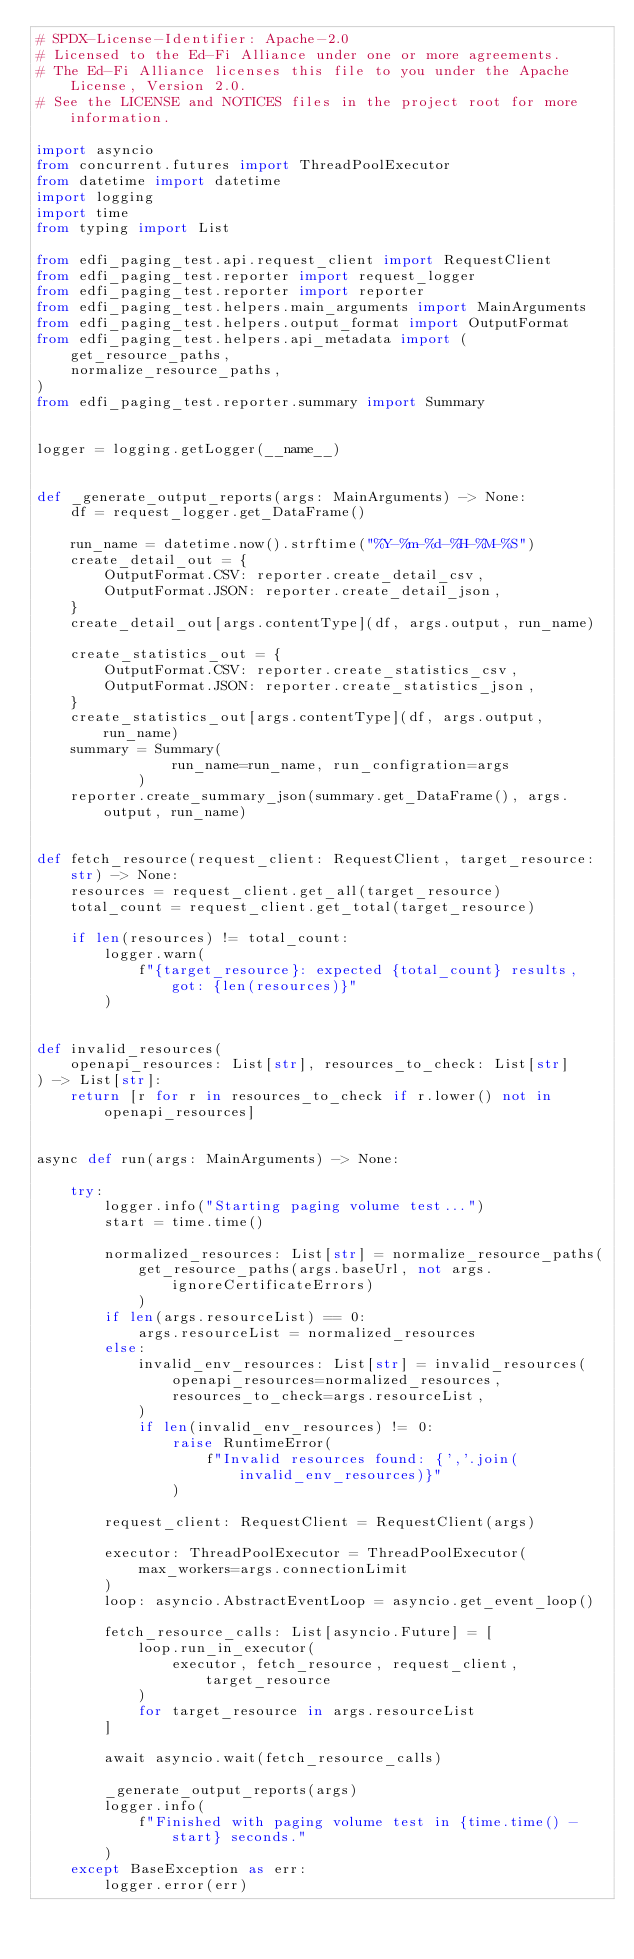<code> <loc_0><loc_0><loc_500><loc_500><_Python_># SPDX-License-Identifier: Apache-2.0
# Licensed to the Ed-Fi Alliance under one or more agreements.
# The Ed-Fi Alliance licenses this file to you under the Apache License, Version 2.0.
# See the LICENSE and NOTICES files in the project root for more information.

import asyncio
from concurrent.futures import ThreadPoolExecutor
from datetime import datetime
import logging
import time
from typing import List

from edfi_paging_test.api.request_client import RequestClient
from edfi_paging_test.reporter import request_logger
from edfi_paging_test.reporter import reporter
from edfi_paging_test.helpers.main_arguments import MainArguments
from edfi_paging_test.helpers.output_format import OutputFormat
from edfi_paging_test.helpers.api_metadata import (
    get_resource_paths,
    normalize_resource_paths,
)
from edfi_paging_test.reporter.summary import Summary


logger = logging.getLogger(__name__)


def _generate_output_reports(args: MainArguments) -> None:
    df = request_logger.get_DataFrame()

    run_name = datetime.now().strftime("%Y-%m-%d-%H-%M-%S")
    create_detail_out = {
        OutputFormat.CSV: reporter.create_detail_csv,
        OutputFormat.JSON: reporter.create_detail_json,
    }
    create_detail_out[args.contentType](df, args.output, run_name)

    create_statistics_out = {
        OutputFormat.CSV: reporter.create_statistics_csv,
        OutputFormat.JSON: reporter.create_statistics_json,
    }
    create_statistics_out[args.contentType](df, args.output, run_name)
    summary = Summary(
                run_name=run_name, run_configration=args
            )
    reporter.create_summary_json(summary.get_DataFrame(), args.output, run_name)


def fetch_resource(request_client: RequestClient, target_resource: str) -> None:
    resources = request_client.get_all(target_resource)
    total_count = request_client.get_total(target_resource)

    if len(resources) != total_count:
        logger.warn(
            f"{target_resource}: expected {total_count} results, got: {len(resources)}"
        )


def invalid_resources(
    openapi_resources: List[str], resources_to_check: List[str]
) -> List[str]:
    return [r for r in resources_to_check if r.lower() not in openapi_resources]


async def run(args: MainArguments) -> None:

    try:
        logger.info("Starting paging volume test...")
        start = time.time()

        normalized_resources: List[str] = normalize_resource_paths(
            get_resource_paths(args.baseUrl, not args.ignoreCertificateErrors)
            )
        if len(args.resourceList) == 0:
            args.resourceList = normalized_resources
        else:
            invalid_env_resources: List[str] = invalid_resources(
                openapi_resources=normalized_resources,
                resources_to_check=args.resourceList,
            )
            if len(invalid_env_resources) != 0:
                raise RuntimeError(
                    f"Invalid resources found: {','.join(invalid_env_resources)}"
                )

        request_client: RequestClient = RequestClient(args)

        executor: ThreadPoolExecutor = ThreadPoolExecutor(
            max_workers=args.connectionLimit
        )
        loop: asyncio.AbstractEventLoop = asyncio.get_event_loop()

        fetch_resource_calls: List[asyncio.Future] = [
            loop.run_in_executor(
                executor, fetch_resource, request_client, target_resource
            )
            for target_resource in args.resourceList
        ]

        await asyncio.wait(fetch_resource_calls)

        _generate_output_reports(args)
        logger.info(
            f"Finished with paging volume test in {time.time() - start} seconds."
        )
    except BaseException as err:
        logger.error(err)
</code> 